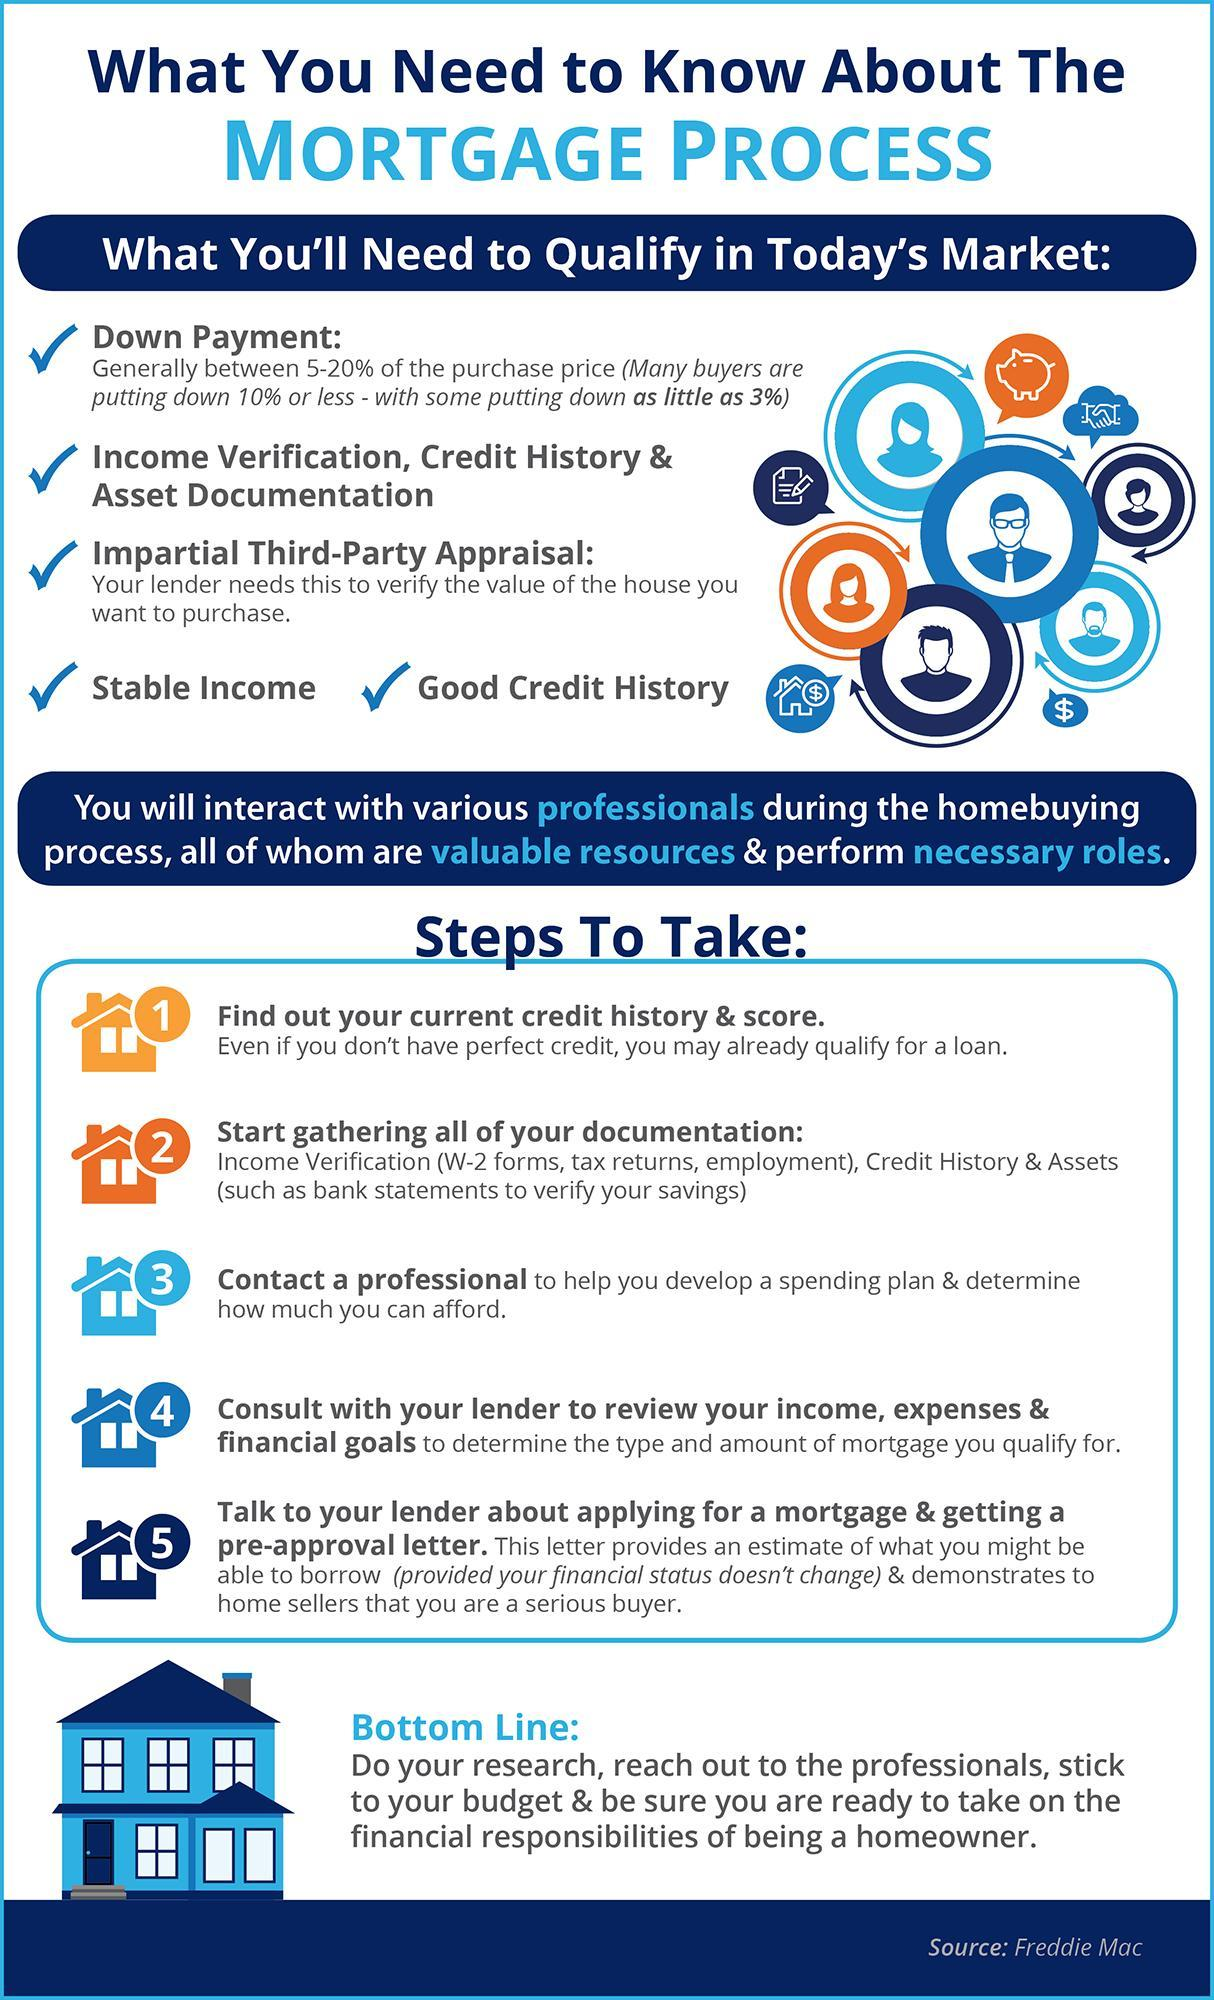How many steps are to be taken for mortgage?
Answer the question with a short phrase. 5 